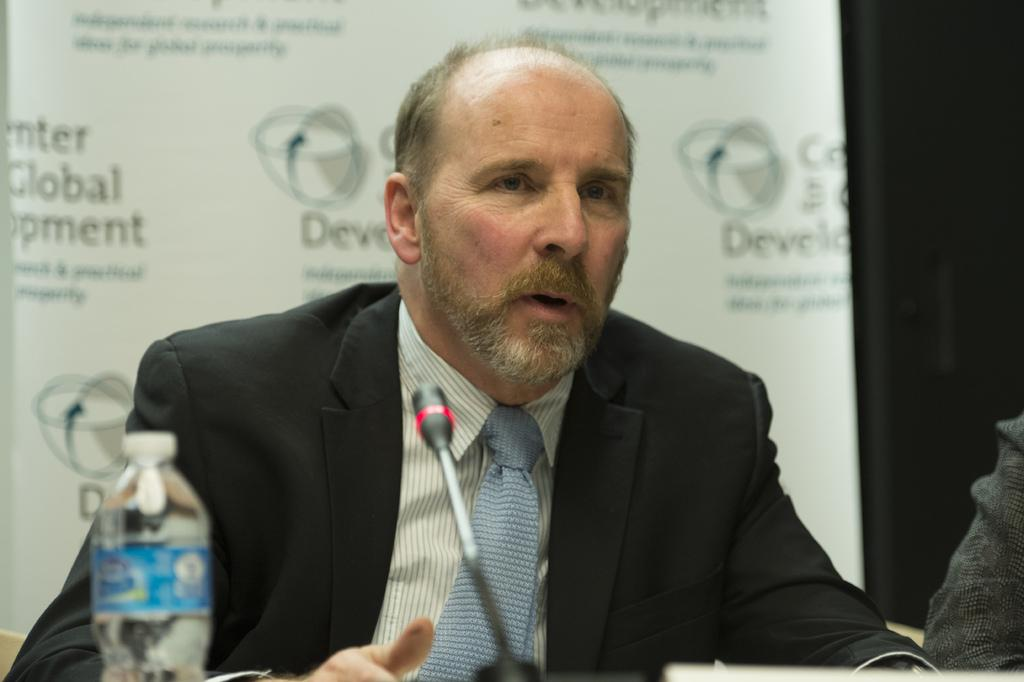What is the man in the image doing? The man is seated and speaking with the help of a microphone. What object is on the table in the image? There is a bottle on the table in the image. What can be seen in the background of the image? There is a hoarding visible in the background of the image. What type of fear can be seen on the horses in the image? There are no horses present in the image, so it is not possible to determine if they are experiencing any fear. 